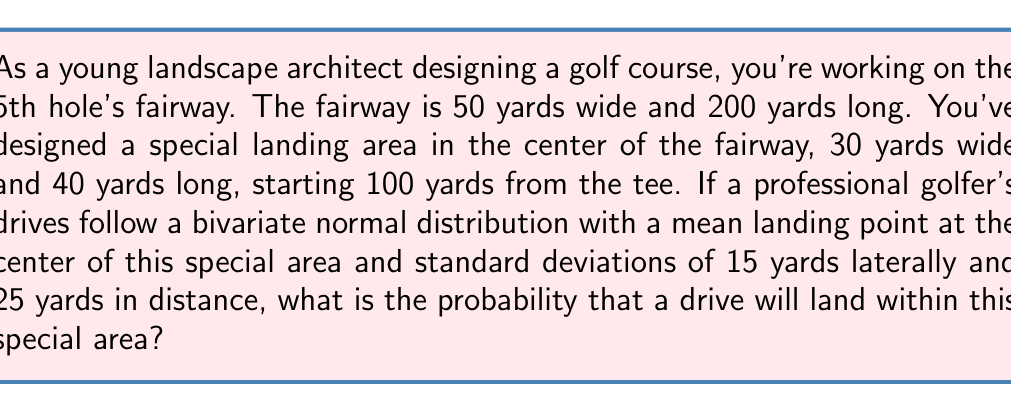Can you answer this question? To solve this problem, we need to use the properties of the bivariate normal distribution and the concept of standardized normal variables (z-scores).

1) First, let's define our variables:
   $\mu_x = 0$ (center of the special area laterally)
   $\mu_y = 120$ (center of the special area in distance from tee)
   $\sigma_x = 15$ (standard deviation laterally)
   $\sigma_y = 25$ (standard deviation in distance)

2) The special area extends:
   Laterally: from -15 to 15 yards from center
   In distance: from 100 to 140 yards from tee

3) We need to convert these boundaries to z-scores:
   $z_{x1} = \frac{-15 - 0}{15} = -1$
   $z_{x2} = \frac{15 - 0}{15} = 1$
   $z_{y1} = \frac{100 - 120}{25} = -0.8$
   $z_{y2} = \frac{140 - 120}{25} = 0.8$

4) The probability is then given by:
   $$P = P(-1 \leq Z_x \leq 1) \cdot P(-0.8 \leq Z_y \leq 0.8)$$

5) Using a standard normal distribution table or calculator:
   $P(-1 \leq Z_x \leq 1) = 0.6826$
   $P(-0.8 \leq Z_y \leq 0.8) = 0.5763$

6) Therefore, the final probability is:
   $$P = 0.6826 \cdot 0.5763 = 0.3933$$
Answer: The probability that a drive will land within the special area is approximately 0.3933 or 39.33%. 